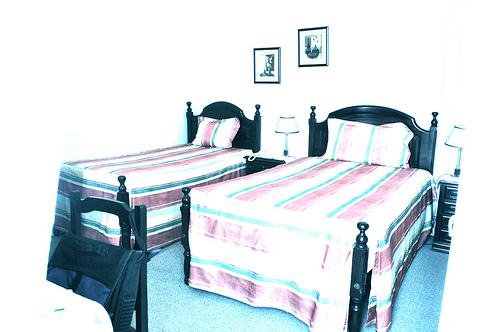Question: where was this taken?
Choices:
A. A bar.
B. A night club.
C. Bedroom.
D. An amusement park.
Answer with the letter. Answer: C Question: how many beds are there?
Choices:
A. 3.
B. 4.
C. 5.
D. 2.
Answer with the letter. Answer: D Question: how many people are there?
Choices:
A. 1.
B. 0.
C. 2.
D. 3.
Answer with the letter. Answer: B Question: what color are the headboards?
Choices:
A. Brown.
B. Black.
C. White.
D. Red.
Answer with the letter. Answer: B 